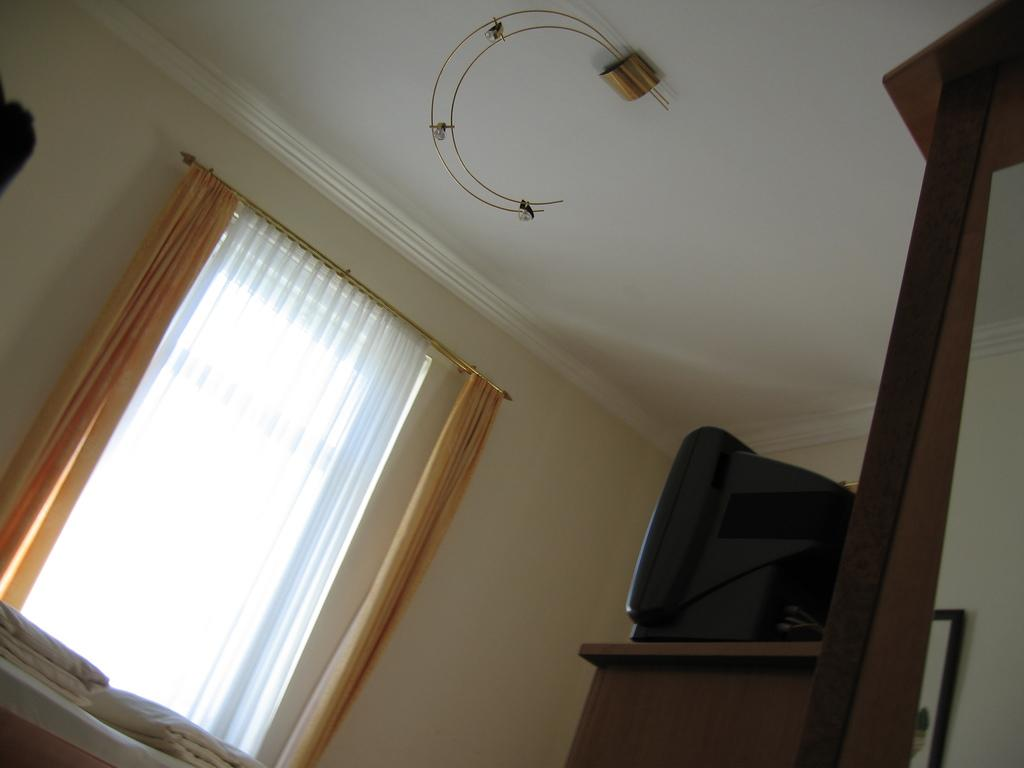Where was the image taken? The image was taken inside a room. What can be seen on the wall in the room? There is a window with curtains on the wall. What is located on the right side of the room? There is a TV on a table on the right side of the room. What are the two metal objects hanging from the ceiling? There are two metal strings hanging from the ceiling. What type of copper roof can be seen in the image? There is no copper roof present in the image; the image is taken inside a room with a window and curtains, a TV on a table, and two metal strings hanging from the ceiling. 